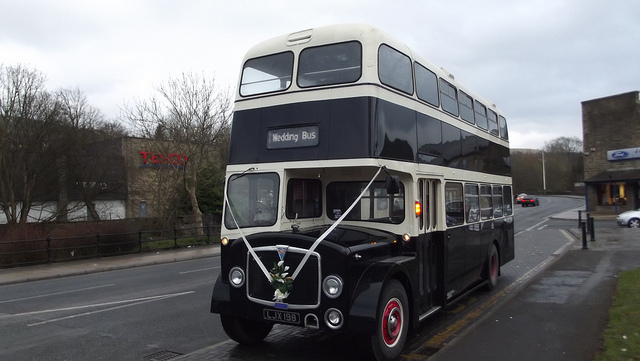Please transcribe the text information in this image. Wedding 